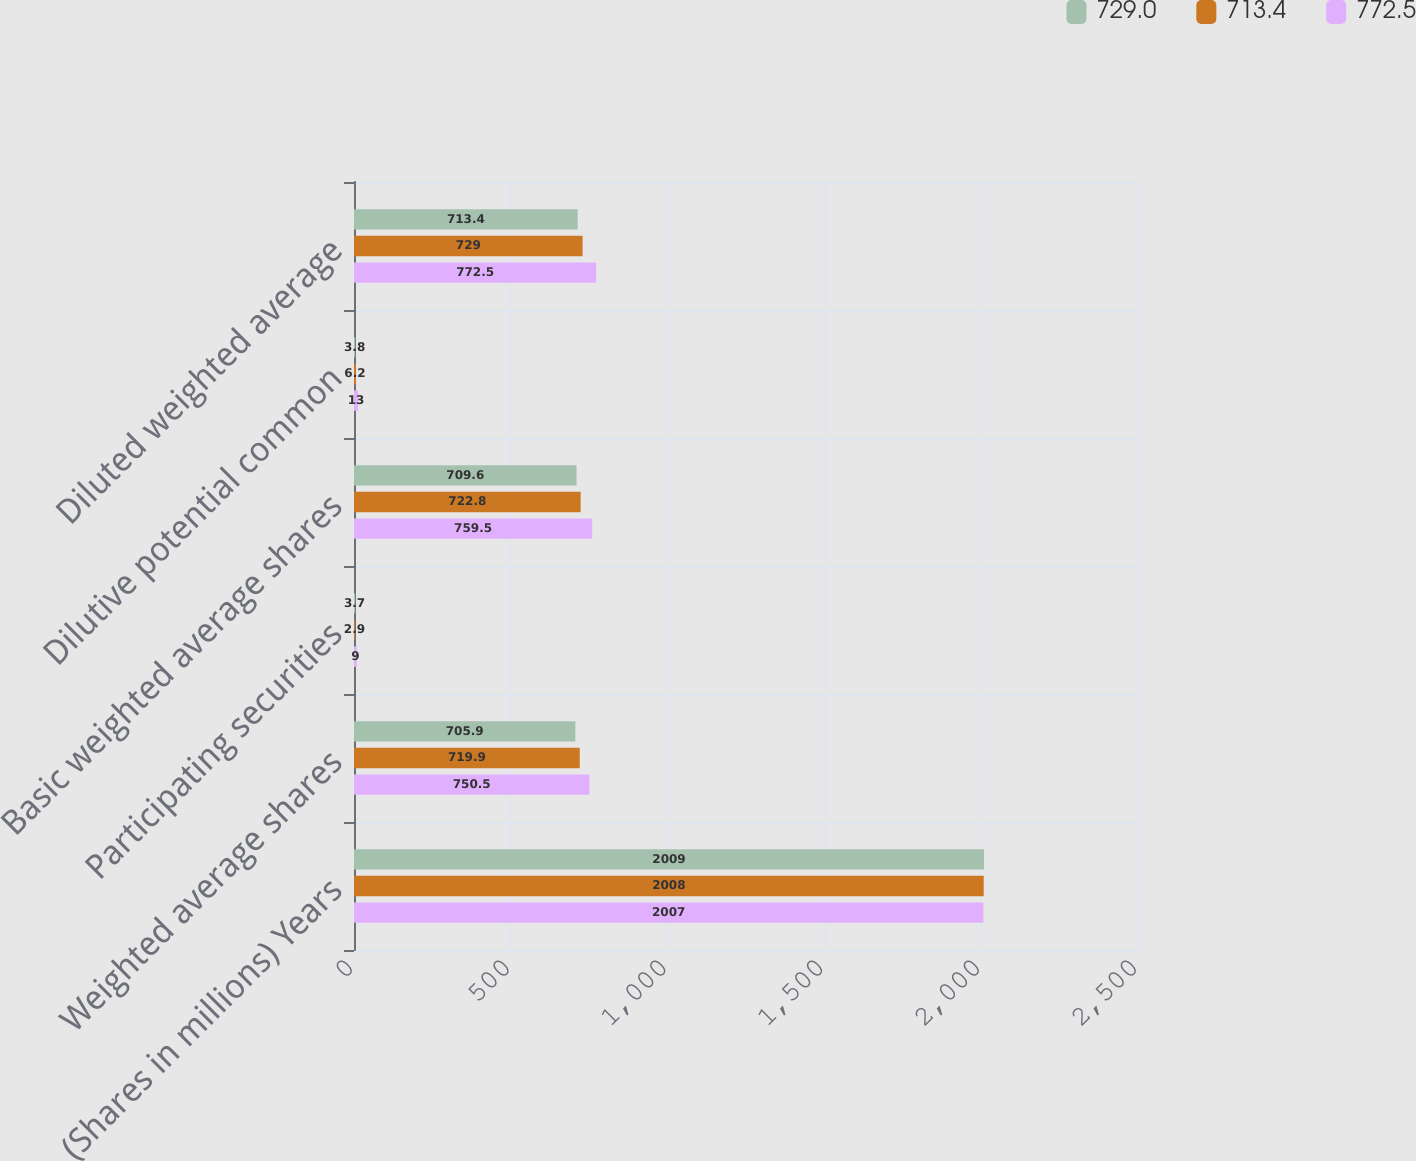<chart> <loc_0><loc_0><loc_500><loc_500><stacked_bar_chart><ecel><fcel>(Shares in millions) Years<fcel>Weighted average shares<fcel>Participating securities<fcel>Basic weighted average shares<fcel>Dilutive potential common<fcel>Diluted weighted average<nl><fcel>729<fcel>2009<fcel>705.9<fcel>3.7<fcel>709.6<fcel>3.8<fcel>713.4<nl><fcel>713.4<fcel>2008<fcel>719.9<fcel>2.9<fcel>722.8<fcel>6.2<fcel>729<nl><fcel>772.5<fcel>2007<fcel>750.5<fcel>9<fcel>759.5<fcel>13<fcel>772.5<nl></chart> 